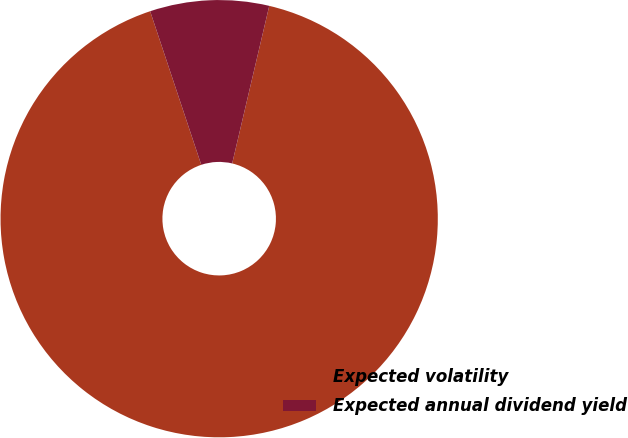<chart> <loc_0><loc_0><loc_500><loc_500><pie_chart><fcel>Expected volatility<fcel>Expected annual dividend yield<nl><fcel>91.21%<fcel>8.79%<nl></chart> 